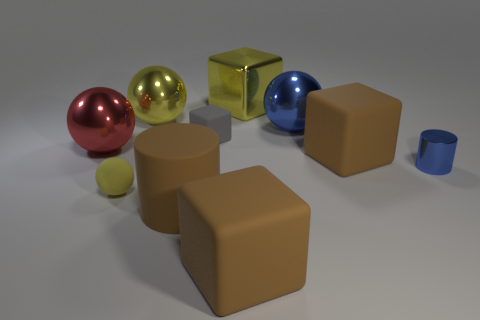There is a blue thing that is to the left of the shiny cylinder; what size is it?
Keep it short and to the point. Large. How many other big metallic objects have the same shape as the gray object?
Offer a very short reply. 1. The small gray rubber thing is what shape?
Your answer should be very brief. Cube. How big is the cube that is to the left of the brown rubber block in front of the brown matte cylinder?
Provide a succinct answer. Small. What number of objects are either large blue metal things or rubber cylinders?
Ensure brevity in your answer.  2. Is the shape of the big blue metallic thing the same as the gray thing?
Give a very brief answer. No. Is there a tiny purple sphere made of the same material as the tiny gray block?
Offer a terse response. No. There is a big brown rubber object that is behind the yellow matte object; is there a big blue ball to the right of it?
Provide a short and direct response. No. There is a sphere on the right side of the brown cylinder; does it have the same size as the yellow block?
Keep it short and to the point. Yes. The blue metallic sphere has what size?
Provide a short and direct response. Large. 